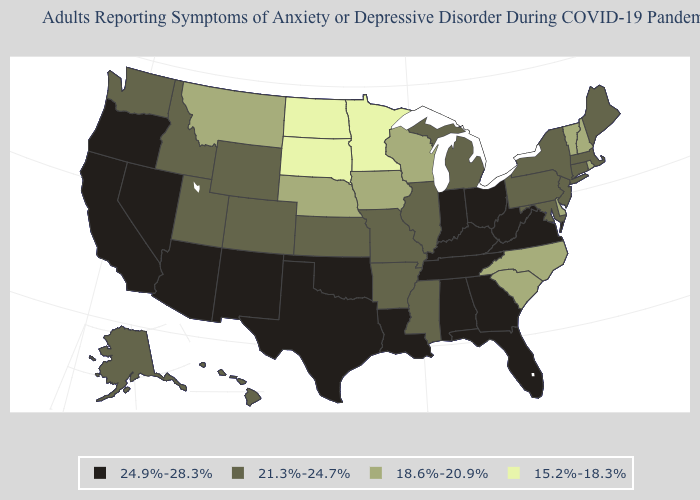Which states have the highest value in the USA?
Write a very short answer. Alabama, Arizona, California, Florida, Georgia, Indiana, Kentucky, Louisiana, Nevada, New Mexico, Ohio, Oklahoma, Oregon, Tennessee, Texas, Virginia, West Virginia. Does the first symbol in the legend represent the smallest category?
Quick response, please. No. Does Alabama have a higher value than Mississippi?
Answer briefly. Yes. Name the states that have a value in the range 18.6%-20.9%?
Quick response, please. Delaware, Iowa, Montana, Nebraska, New Hampshire, North Carolina, Rhode Island, South Carolina, Vermont, Wisconsin. Among the states that border Kentucky , does Missouri have the highest value?
Short answer required. No. Does Ohio have the highest value in the MidWest?
Concise answer only. Yes. How many symbols are there in the legend?
Give a very brief answer. 4. Which states hav the highest value in the Northeast?
Give a very brief answer. Connecticut, Maine, Massachusetts, New Jersey, New York, Pennsylvania. Name the states that have a value in the range 24.9%-28.3%?
Answer briefly. Alabama, Arizona, California, Florida, Georgia, Indiana, Kentucky, Louisiana, Nevada, New Mexico, Ohio, Oklahoma, Oregon, Tennessee, Texas, Virginia, West Virginia. Which states have the lowest value in the West?
Be succinct. Montana. Does Florida have a lower value than Michigan?
Keep it brief. No. What is the lowest value in states that border Nebraska?
Give a very brief answer. 15.2%-18.3%. What is the value of South Carolina?
Concise answer only. 18.6%-20.9%. What is the highest value in states that border Michigan?
Answer briefly. 24.9%-28.3%. What is the value of Michigan?
Answer briefly. 21.3%-24.7%. 